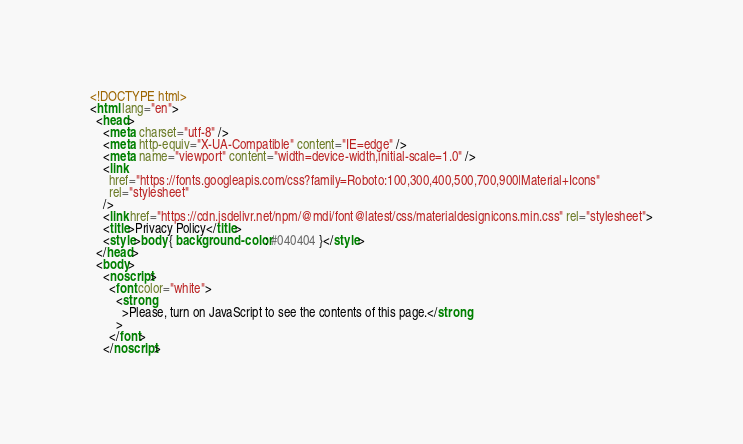Convert code to text. <code><loc_0><loc_0><loc_500><loc_500><_HTML_><!DOCTYPE html>
<html lang="en">
  <head>
    <meta charset="utf-8" />
    <meta http-equiv="X-UA-Compatible" content="IE=edge" />
    <meta name="viewport" content="width=device-width,initial-scale=1.0" />
    <link
      href="https://fonts.googleapis.com/css?family=Roboto:100,300,400,500,700,900|Material+Icons"
      rel="stylesheet"
    />
    <link href="https://cdn.jsdelivr.net/npm/@mdi/font@latest/css/materialdesignicons.min.css" rel="stylesheet">
    <title>Privacy Policy</title>
    <style>body { background-color: #040404 }</style>
  </head>
  <body>
    <noscript>
      <font color="white">
        <strong
          >Please, turn on JavaScript to see the contents of this page.</strong
        >
      </font>
    </noscript></code> 